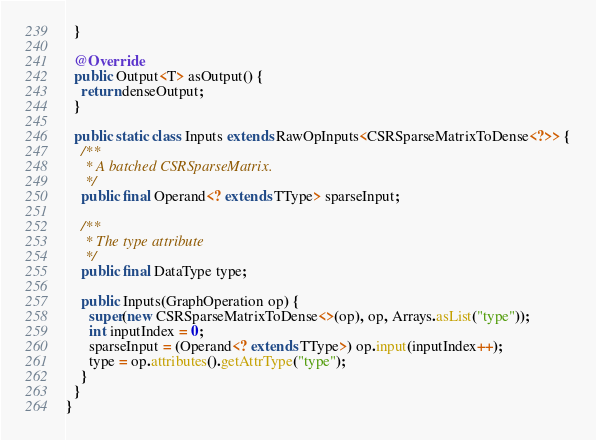<code> <loc_0><loc_0><loc_500><loc_500><_Java_>  }

  @Override
  public Output<T> asOutput() {
    return denseOutput;
  }

  public static class Inputs extends RawOpInputs<CSRSparseMatrixToDense<?>> {
    /**
     * A batched CSRSparseMatrix.
     */
    public final Operand<? extends TType> sparseInput;

    /**
     * The type attribute
     */
    public final DataType type;

    public Inputs(GraphOperation op) {
      super(new CSRSparseMatrixToDense<>(op), op, Arrays.asList("type"));
      int inputIndex = 0;
      sparseInput = (Operand<? extends TType>) op.input(inputIndex++);
      type = op.attributes().getAttrType("type");
    }
  }
}
</code> 